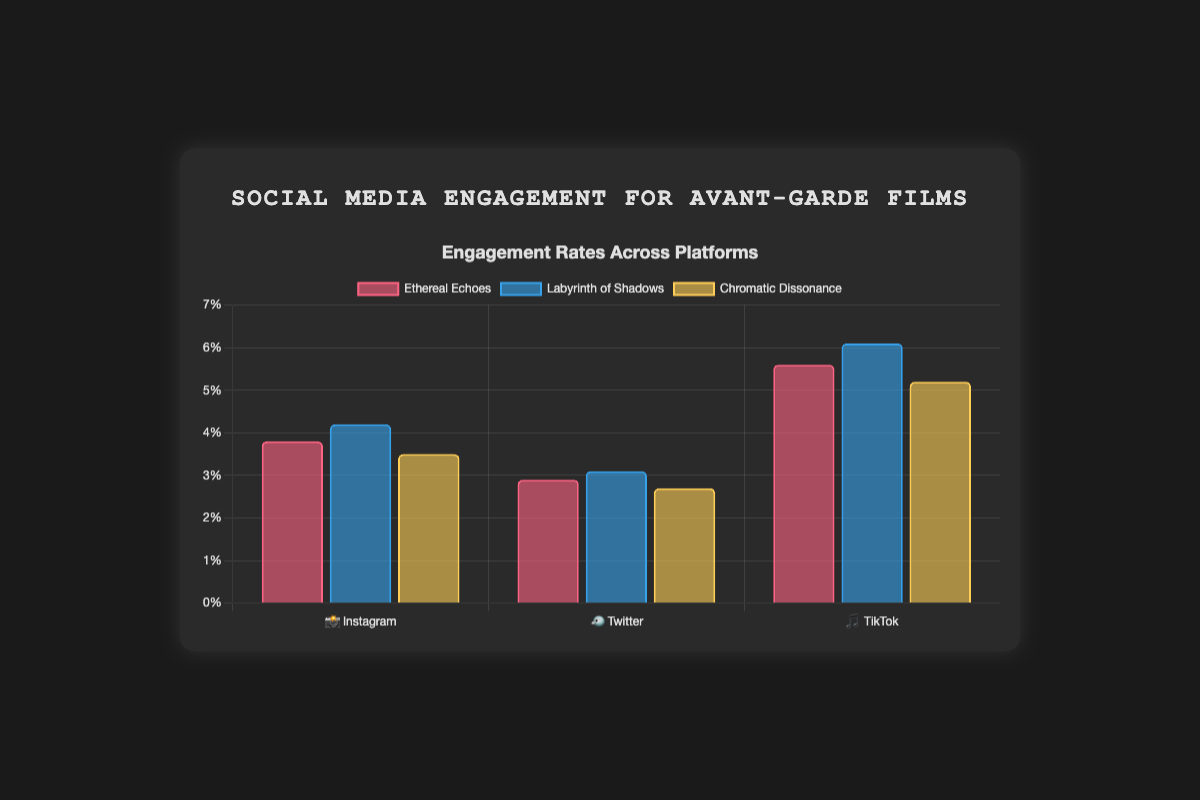What is the title of the chart? The title of the chart is displayed at the top of the figure, and it reads “Social Media Engagement for Avant-Garde Films.”
Answer: Social Media Engagement for Avant-Garde Films Which film has the highest engagement rate on TikTok 🎵? The engagement rates for TikTok 🎵 are listed for each film. "Labyrinth of Shadows” has the highest engagement rate of 6.1%.
Answer: Labyrinth of Shadows What is the engagement rate for "Chromatic Dissonance" on Instagram 📸? The engagement rates are broken down by film and platform. Chromatic Dissonance on Instagram 📸 shows an engagement rate of 3.5%.
Answer: 3.5% How many followers did "Ethereal Echoes" gain on Twitter 🐦? Within the Twitter 🐦 data, each film's followers gained are listed, showing “Ethereal Echoes” gained 720 followers.
Answer: 720 Compare the engagement rates of "Labyrinth of Shadows" across all platforms. Which platform shows the highest engagement? For "Labyrinth of Shadows," engagement rates are 4.2% (Instagram 📸), 3.1% (Twitter 🐦), and 6.1% (TikTok 🎵). TikTok 🎵 shows the highest engagement rate at 6.1%.
Answer: TikTok 🎵 What is the average engagement rate for "Ethereal Echoes" across all platforms? Sum the engagement rates for "Ethereal Echoes" (3.8% + 2.9% + 5.6%) = 12.3, then divide by 3 platforms. 12.3/3 = 4.1%
Answer: 4.1% Which platform has the lowest engagement rate for "Chromatic Dissonance"? The engagement rates for "Chromatic Dissonance" are 3.5% (Instagram 📸), 2.7% (Twitter 🐦), 5.2% (TikTok 🎵). Twitter 🐦 has the lowest engagement rate at 2.7%.
Answer: Twitter 🐦 How does the number of followers gained by "Labyrinth of Shadows" on Instagram 📸 compare to TikTok 🎵? "Labyrinth of Shadows" gained 1680 followers on Instagram 📸 and 2450 on TikTok 🎵. TikTok 🎵 has more followers gained by 770.
Answer: TikTok 🎵 What is the total number of followers gained by "Chromatic Dissonance" across all platforms? Add the number of followers gained on each platform: 980 (Instagram 📸) + 610 (Twitter 🐦) + 1890 (TikTok 🎵) = 3480
Answer: 3480 Rank the films from highest to lowest engagement rate on Instagram 📸. On Instagram 📸, the engagement rates are as follows: Labyrinth of Shadows (4.2%), Ethereal Echoes (3.8%), Chromatic Dissonance (3.5%). Therefore, the ranking is Labyrinth of Shadows > Ethereal Echoes > Chromatic Dissonance.
Answer: Labyrinth of Shadows > Ethereal Echoes > Chromatic Dissonance 